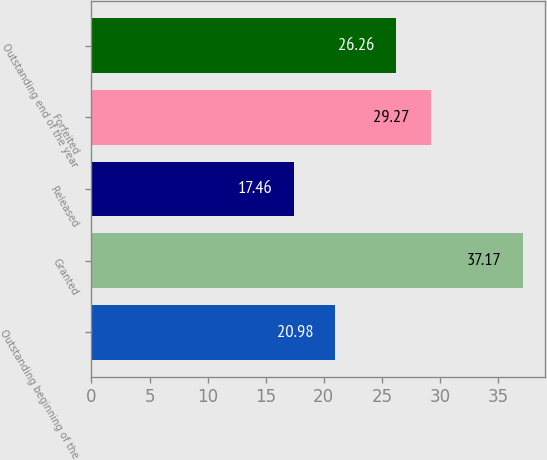<chart> <loc_0><loc_0><loc_500><loc_500><bar_chart><fcel>Outstanding beginning of the<fcel>Granted<fcel>Released<fcel>Forfeited<fcel>Outstanding end of the year<nl><fcel>20.98<fcel>37.17<fcel>17.46<fcel>29.27<fcel>26.26<nl></chart> 